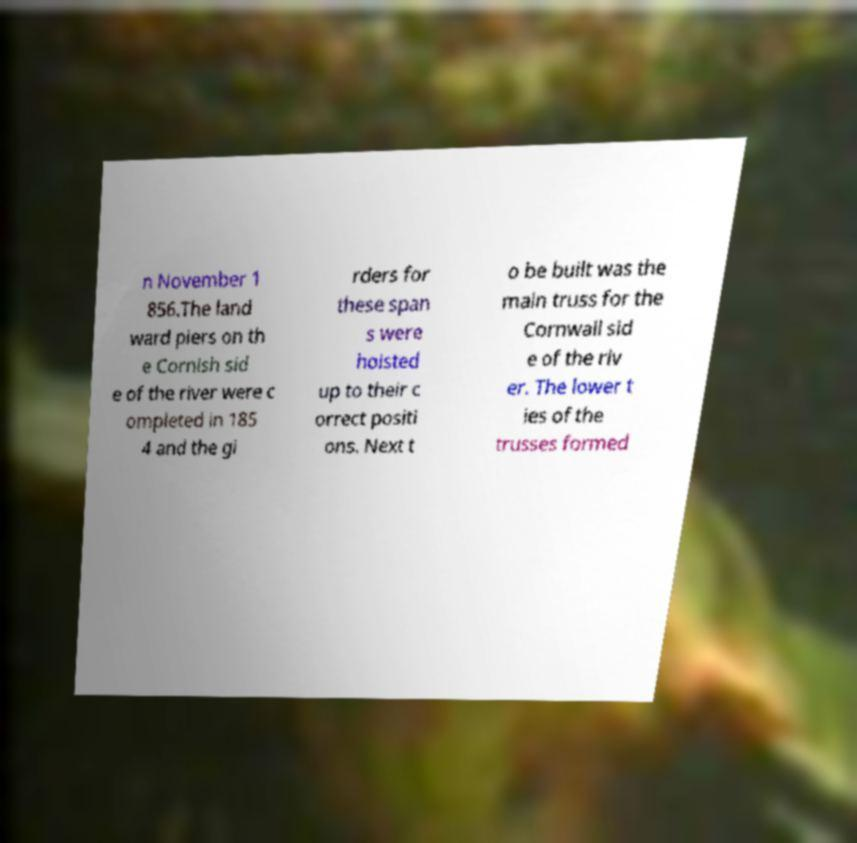For documentation purposes, I need the text within this image transcribed. Could you provide that? n November 1 856.The land ward piers on th e Cornish sid e of the river were c ompleted in 185 4 and the gi rders for these span s were hoisted up to their c orrect positi ons. Next t o be built was the main truss for the Cornwall sid e of the riv er. The lower t ies of the trusses formed 